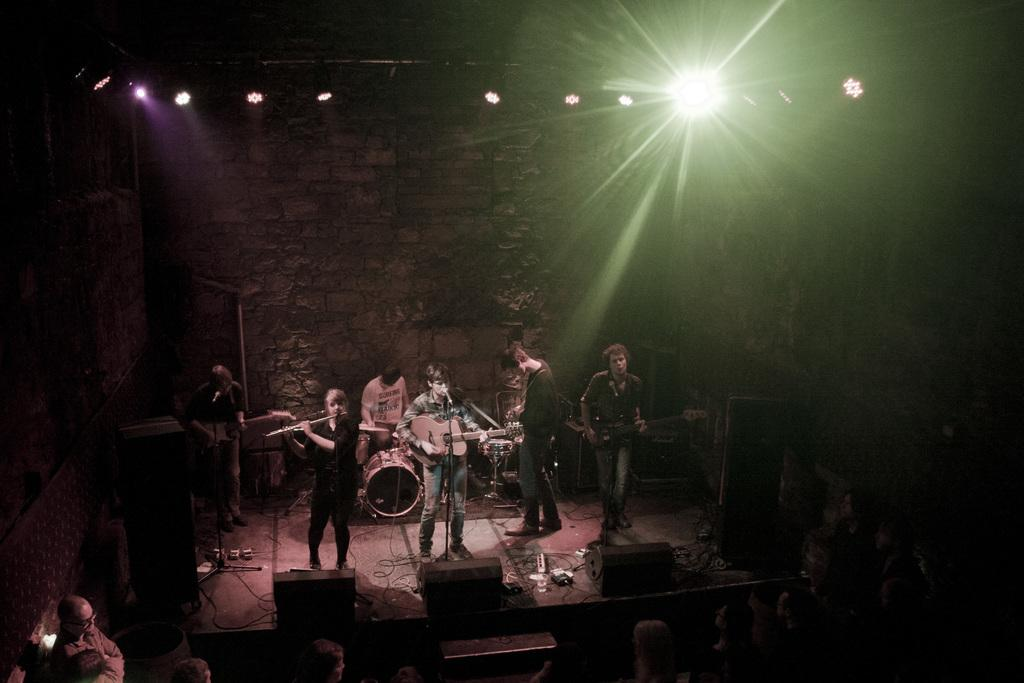What are the people on stage doing? The people on stage are performing, with some holding a guitar, some holding a flute, and some playing drums. What can be observed about the audience in the image? There are people watching the performers on stage. What type of jeans is the person holding the parcel wearing in the image? There is no person holding a parcel or wearing jeans in the image. What is the aftermath of the performance in the image? The image does not show the aftermath of the performance, as it captures the ongoing event. 